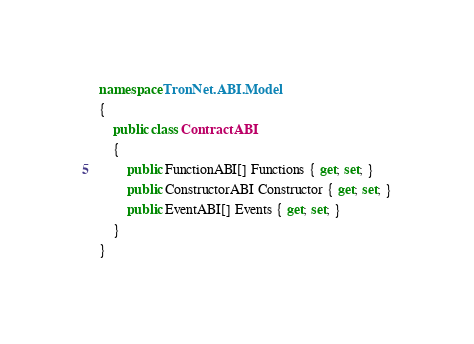<code> <loc_0><loc_0><loc_500><loc_500><_C#_>namespace TronNet.ABI.Model
{
    public class ContractABI
    {
        public FunctionABI[] Functions { get; set; }
        public ConstructorABI Constructor { get; set; }
        public EventABI[] Events { get; set; }
    }
}</code> 